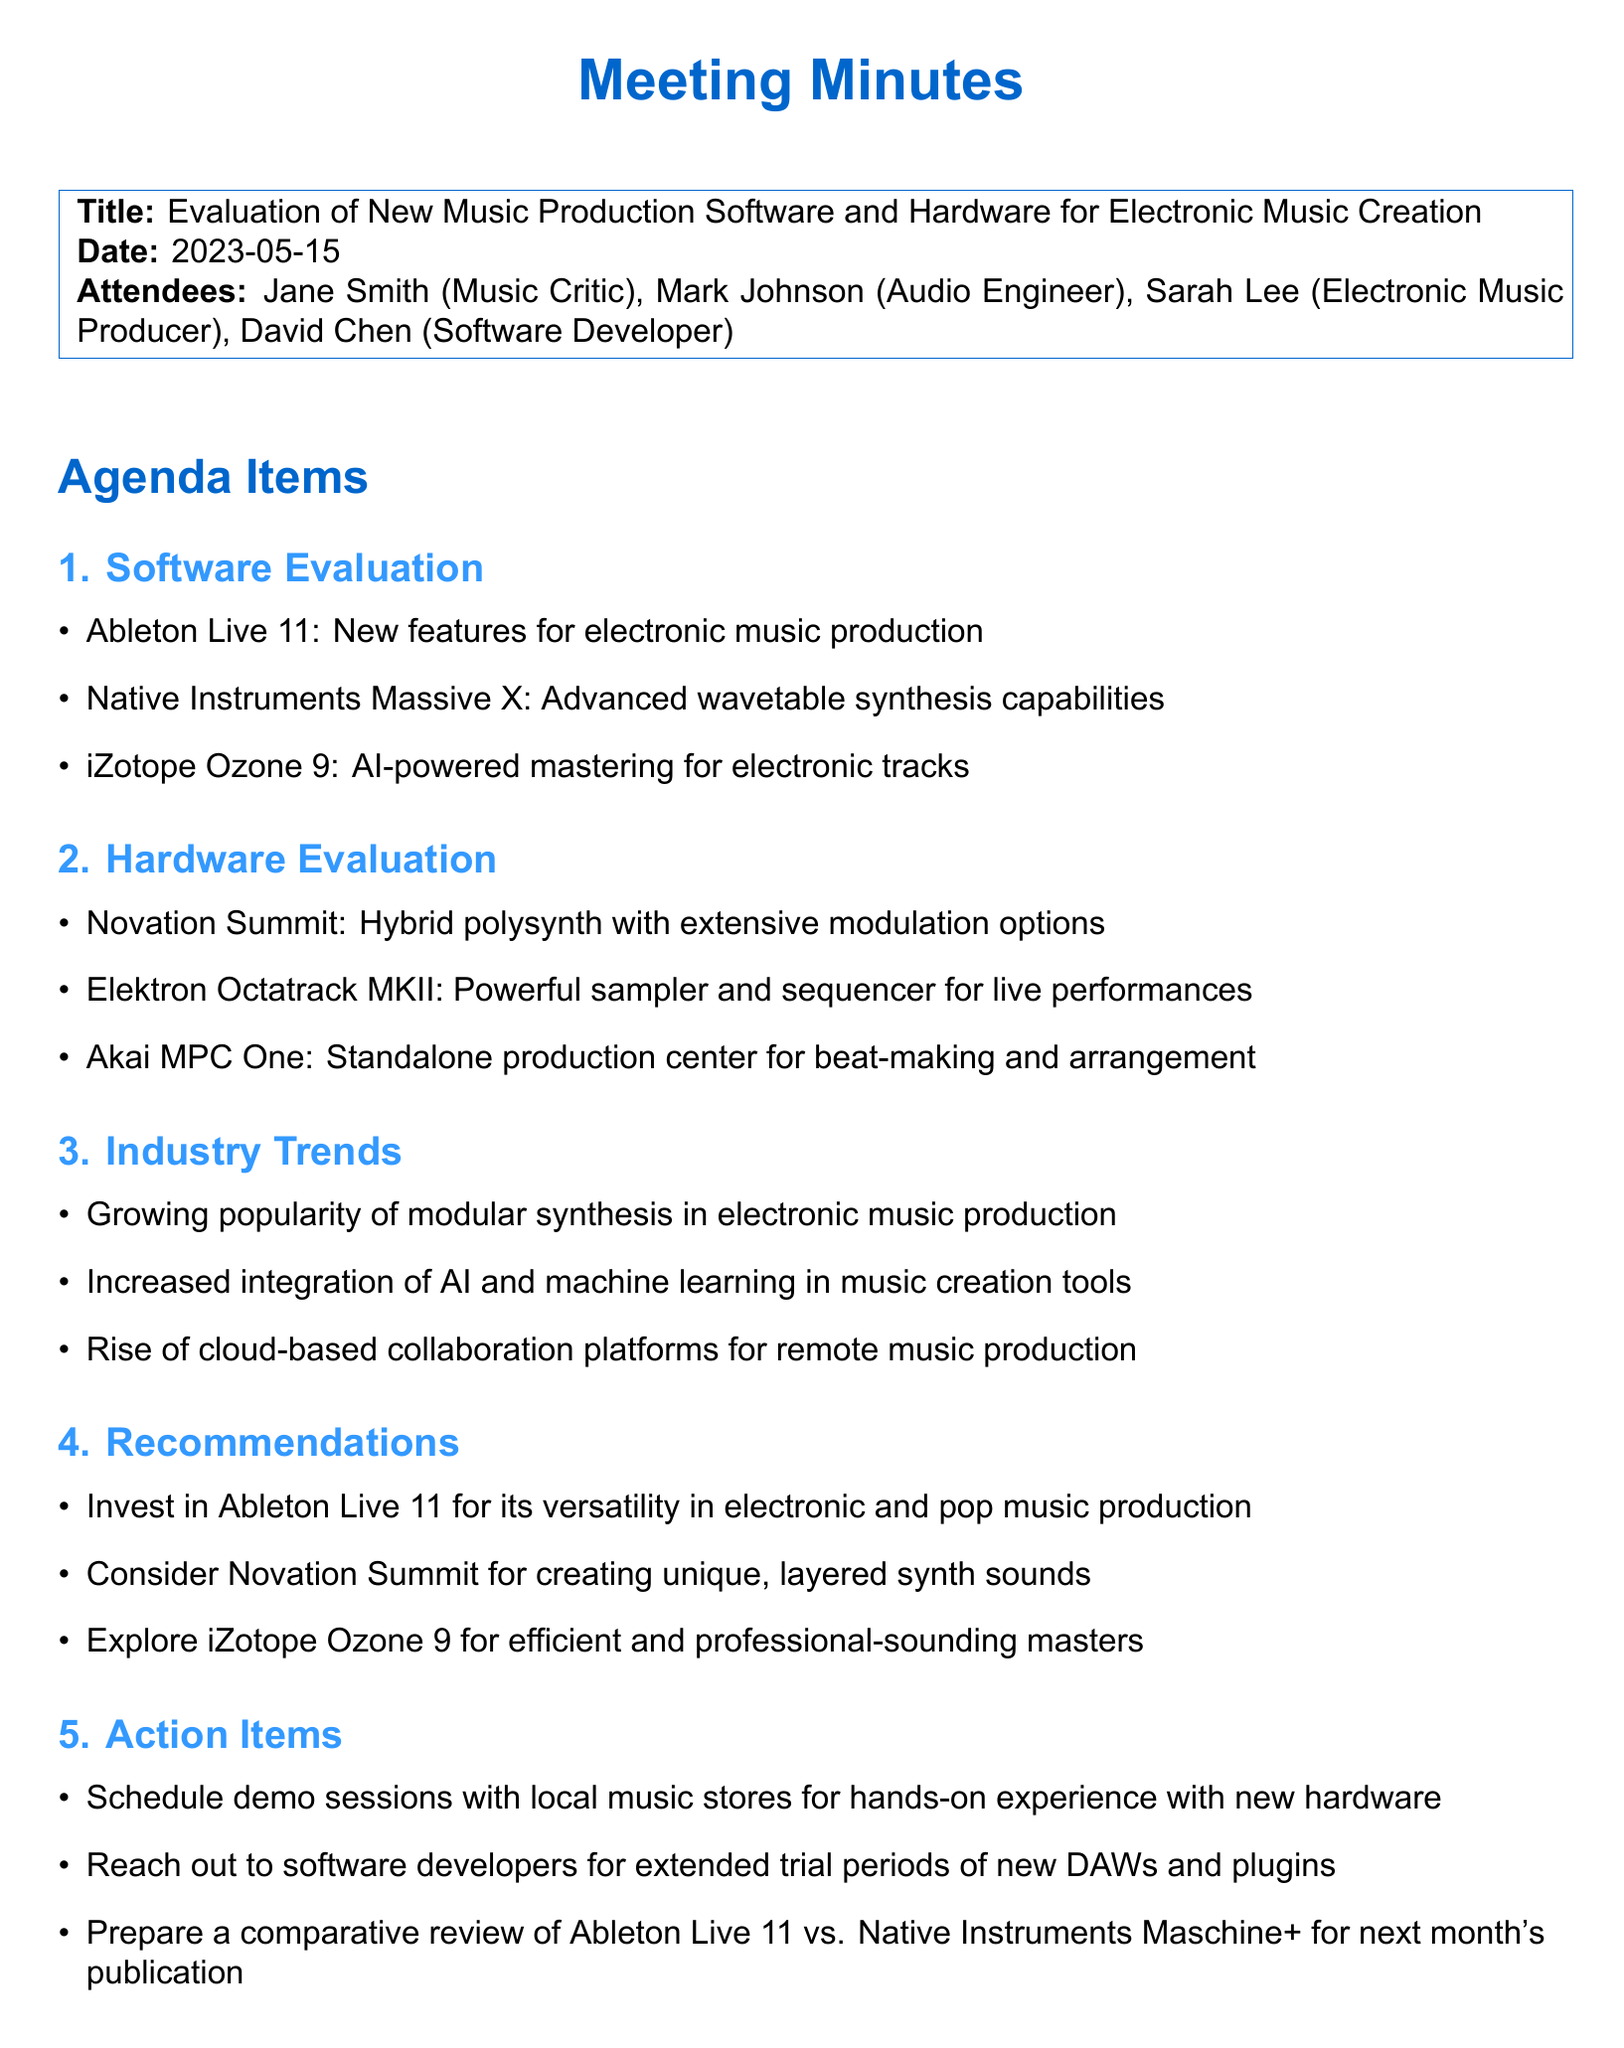What is the title of the meeting? The title is specified at the beginning of the document.
Answer: Evaluation of New Music Production Software and Hardware for Electronic Music Creation Who attended the meeting? The attendees' names and roles are listed in the document.
Answer: Jane Smith, Mark Johnson, Sarah Lee, David Chen What is one of the software evaluated in the meeting? The document lists three software evaluations under the Software Evaluation agenda item.
Answer: Ableton Live 11 What is one of the hardware devices evaluated? One hardware item is noted under the Hardware Evaluation agenda item.
Answer: Novation Summit What are the trends mentioned in the document? The trends identified are listed under the Industry Trends section in the document.
Answer: Growing popularity of modular synthesis What is one recommendation from the meeting? The document contains several recommendations listed under Recommendations.
Answer: Invest in Ableton Live 11 What action item was suggested regarding hardware? Action items are listed, and one involves hardware experience.
Answer: Schedule demo sessions with local music stores What date was the meeting held? The date of the meeting is explicitly mentioned at the start of the document.
Answer: 2023-05-15 How many attendees were there? The number of attendees can be counted from the list in the document.
Answer: Four 